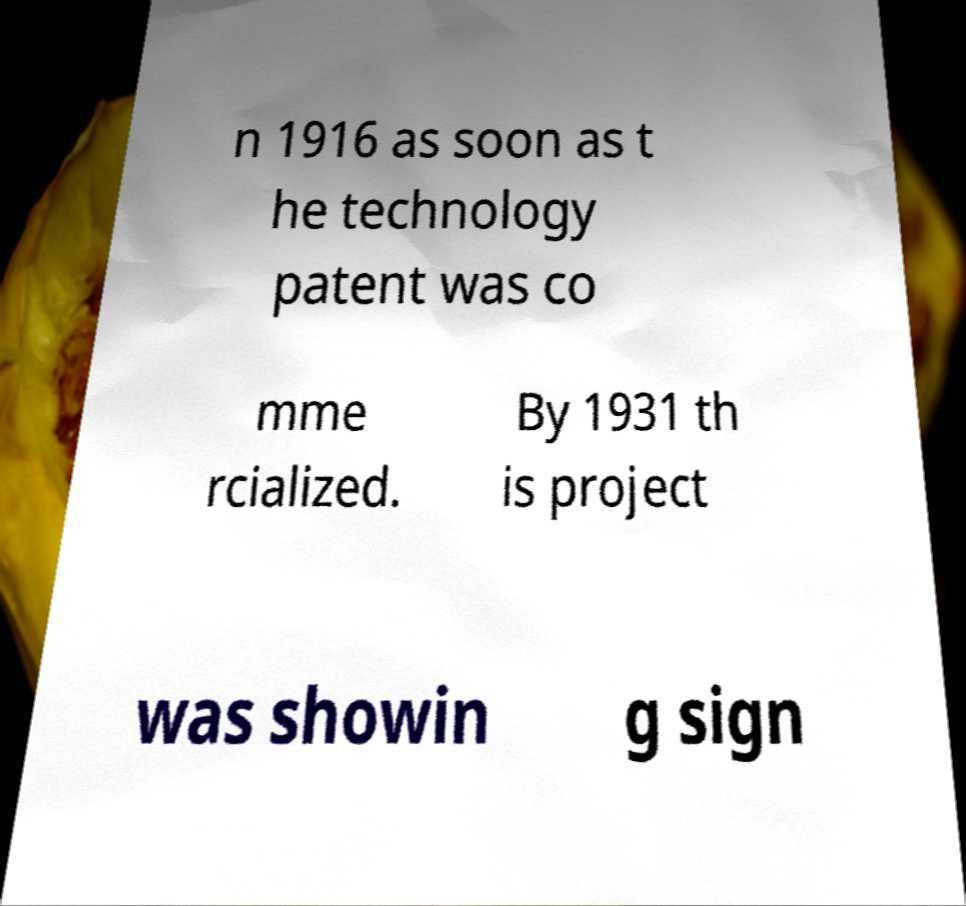For documentation purposes, I need the text within this image transcribed. Could you provide that? n 1916 as soon as t he technology patent was co mme rcialized. By 1931 th is project was showin g sign 